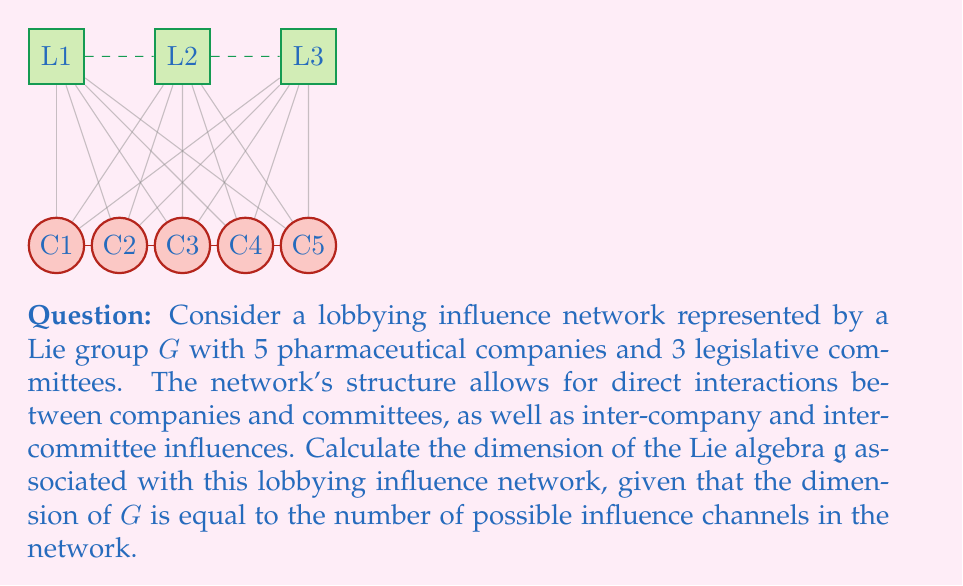Give your solution to this math problem. To calculate the dimension of the Lie algebra $\mathfrak{g}$, we need to determine the number of possible influence channels in the network. Let's break this down step-by-step:

1) Company-Committee interactions:
   - Each of the 5 companies can influence each of the 3 committees
   - Number of these channels = $5 \times 3 = 15$

2) Inter-Company influences:
   - In a network of 5 companies, each company can influence 4 others
   - Total number of inter-company channels = $5 \times 4 = 20$

3) Inter-Committee influences:
   - With 3 committees, each committee can influence 2 others
   - Total number of inter-committee channels = $3 \times 2 = 6$

4) Total number of influence channels:
   $$ 15 + 20 + 6 = 41 $$

5) The dimension of the Lie group $G$ is equal to the number of influence channels. Therefore, $\dim G = 41$

6) For matrix Lie groups, the dimension of the Lie algebra $\mathfrak{g}$ is equal to the dimension of the corresponding Lie group $G$. Thus:

   $$ \dim \mathfrak{g} = \dim G = 41 $$

Therefore, the dimension of the Lie algebra $\mathfrak{g}$ associated with this lobbying influence network is 41.
Answer: $41$ 